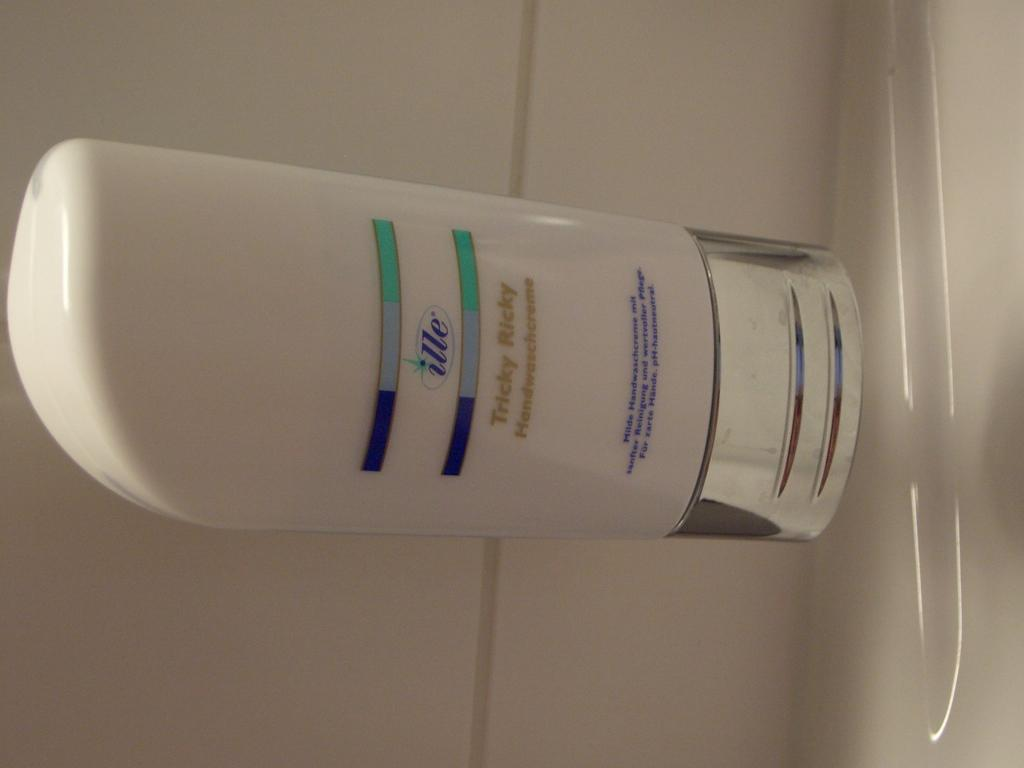<image>
Create a compact narrative representing the image presented. A bottle of ille Tricky Ricky is white and silver with blue and green details. 